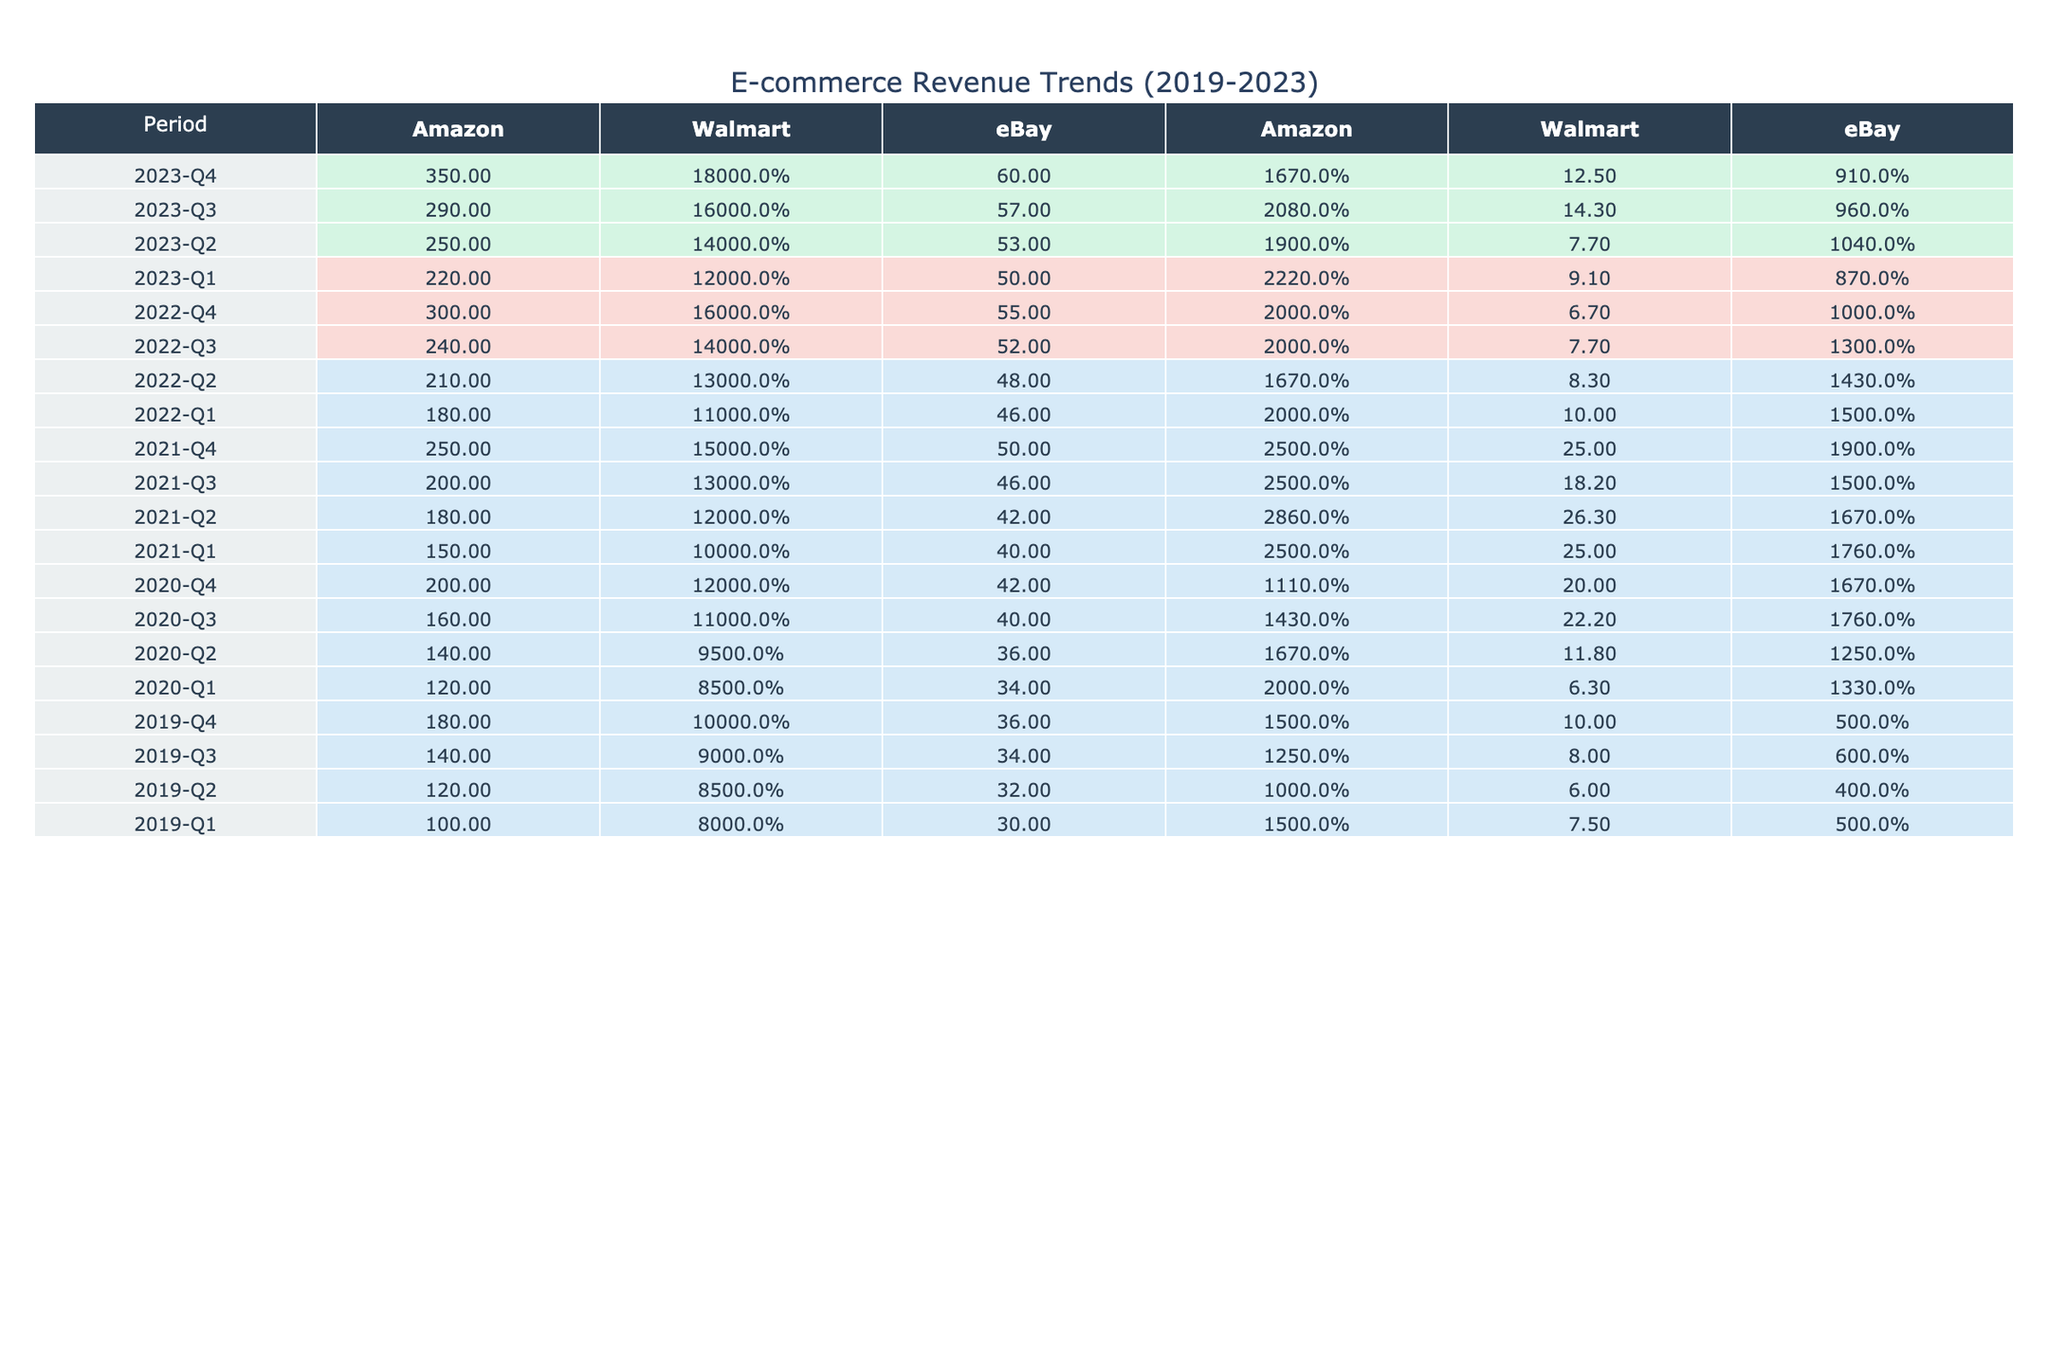What was the total revenue of Amazon in Q2 2021? Looking at the table for the year 2021 and specifically for the second quarter, the Total Revenue for Amazon is listed as 180 million dollars.
Answer: 180 million dollars Which e-commerce business had the highest revenue growth in Q4 2022? Reviewing the table for Q4 2022, Amazon shows a revenue growth of 20.0%, eBay shows 10.0%, and Walmart shows 6.7%. Among these, Amazon had the highest revenue growth percentage.
Answer: Amazon What is the average total revenue of Walmart for all quarters in 2020? To find the average total revenue for Walmart in 2020, we add the revenues for each quarter: 85 + 95 + 110 + 120 = 410 million dollars. There are 4 quarters, so the average is 410/4 = 102.5 million dollars.
Answer: 102.5 million dollars Did eBay experience a revenue decline in any quarter during 2020? By examining the revenue growth percentages, eBay's numbers for 2020 all show positive growth rates: 13.3%, 12.5%, 17.6%, and 16.7%. Since there are no negative growth percentages, it indicates there was no revenue decline.
Answer: No What was the difference in total revenue for Amazon between Q1 2022 and Q1 2023? In Q1 2022, the total revenue for Amazon was 180 million dollars, and in Q1 2023, it was 220 million dollars. The difference is 220 - 180 = 40 million dollars.
Answer: 40 million dollars What percentage growth did Walmart achieve from Q3 2022 to Q4 2022? For Walmart, the revenue in Q3 2022 was 140 million dollars, and in Q4 2022 it was 160 million dollars. The difference is 160 - 140 = 20 million dollars. The percentage growth is (20/140) * 100 = 14.3%.
Answer: 14.3% What was the total revenue for eBay in 2021? To find the total revenue for eBay in 2021, we sum the revenues from all four quarters: 40 + 42 + 46 + 50 = 178 million dollars.
Answer: 178 million dollars Which quarter in 2023 saw the highest revenue for Walmart? Reviewing the table for Walmart in 2023 shows the quarterly revenues: Q1 - 120 million, Q2 - 140 million, Q3 - 160 million, Q4 - 180 million. The highest revenue is in Q4 with 180 million dollars.
Answer: Q4 2023 